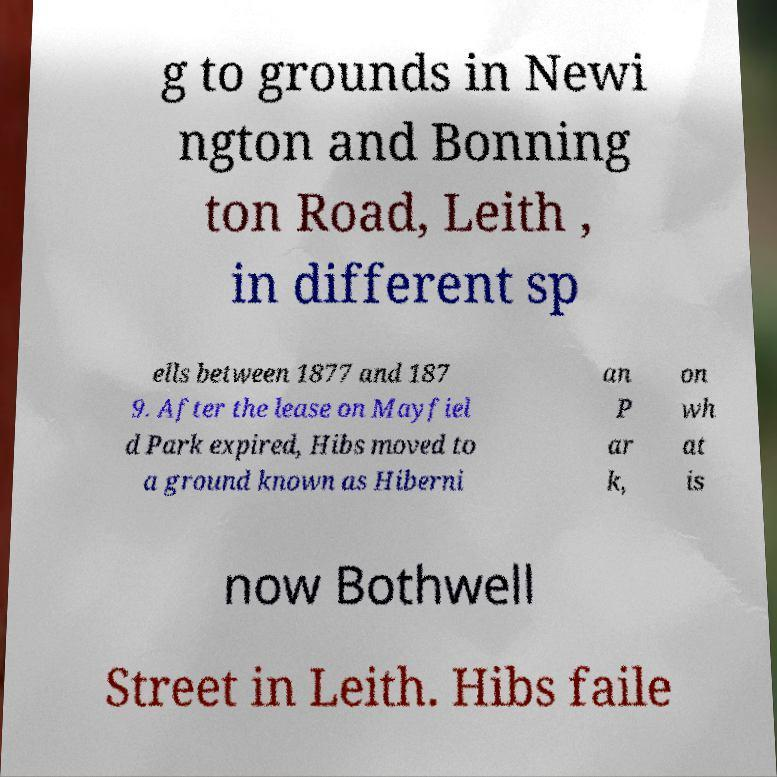Please identify and transcribe the text found in this image. g to grounds in Newi ngton and Bonning ton Road, Leith , in different sp ells between 1877 and 187 9. After the lease on Mayfiel d Park expired, Hibs moved to a ground known as Hiberni an P ar k, on wh at is now Bothwell Street in Leith. Hibs faile 